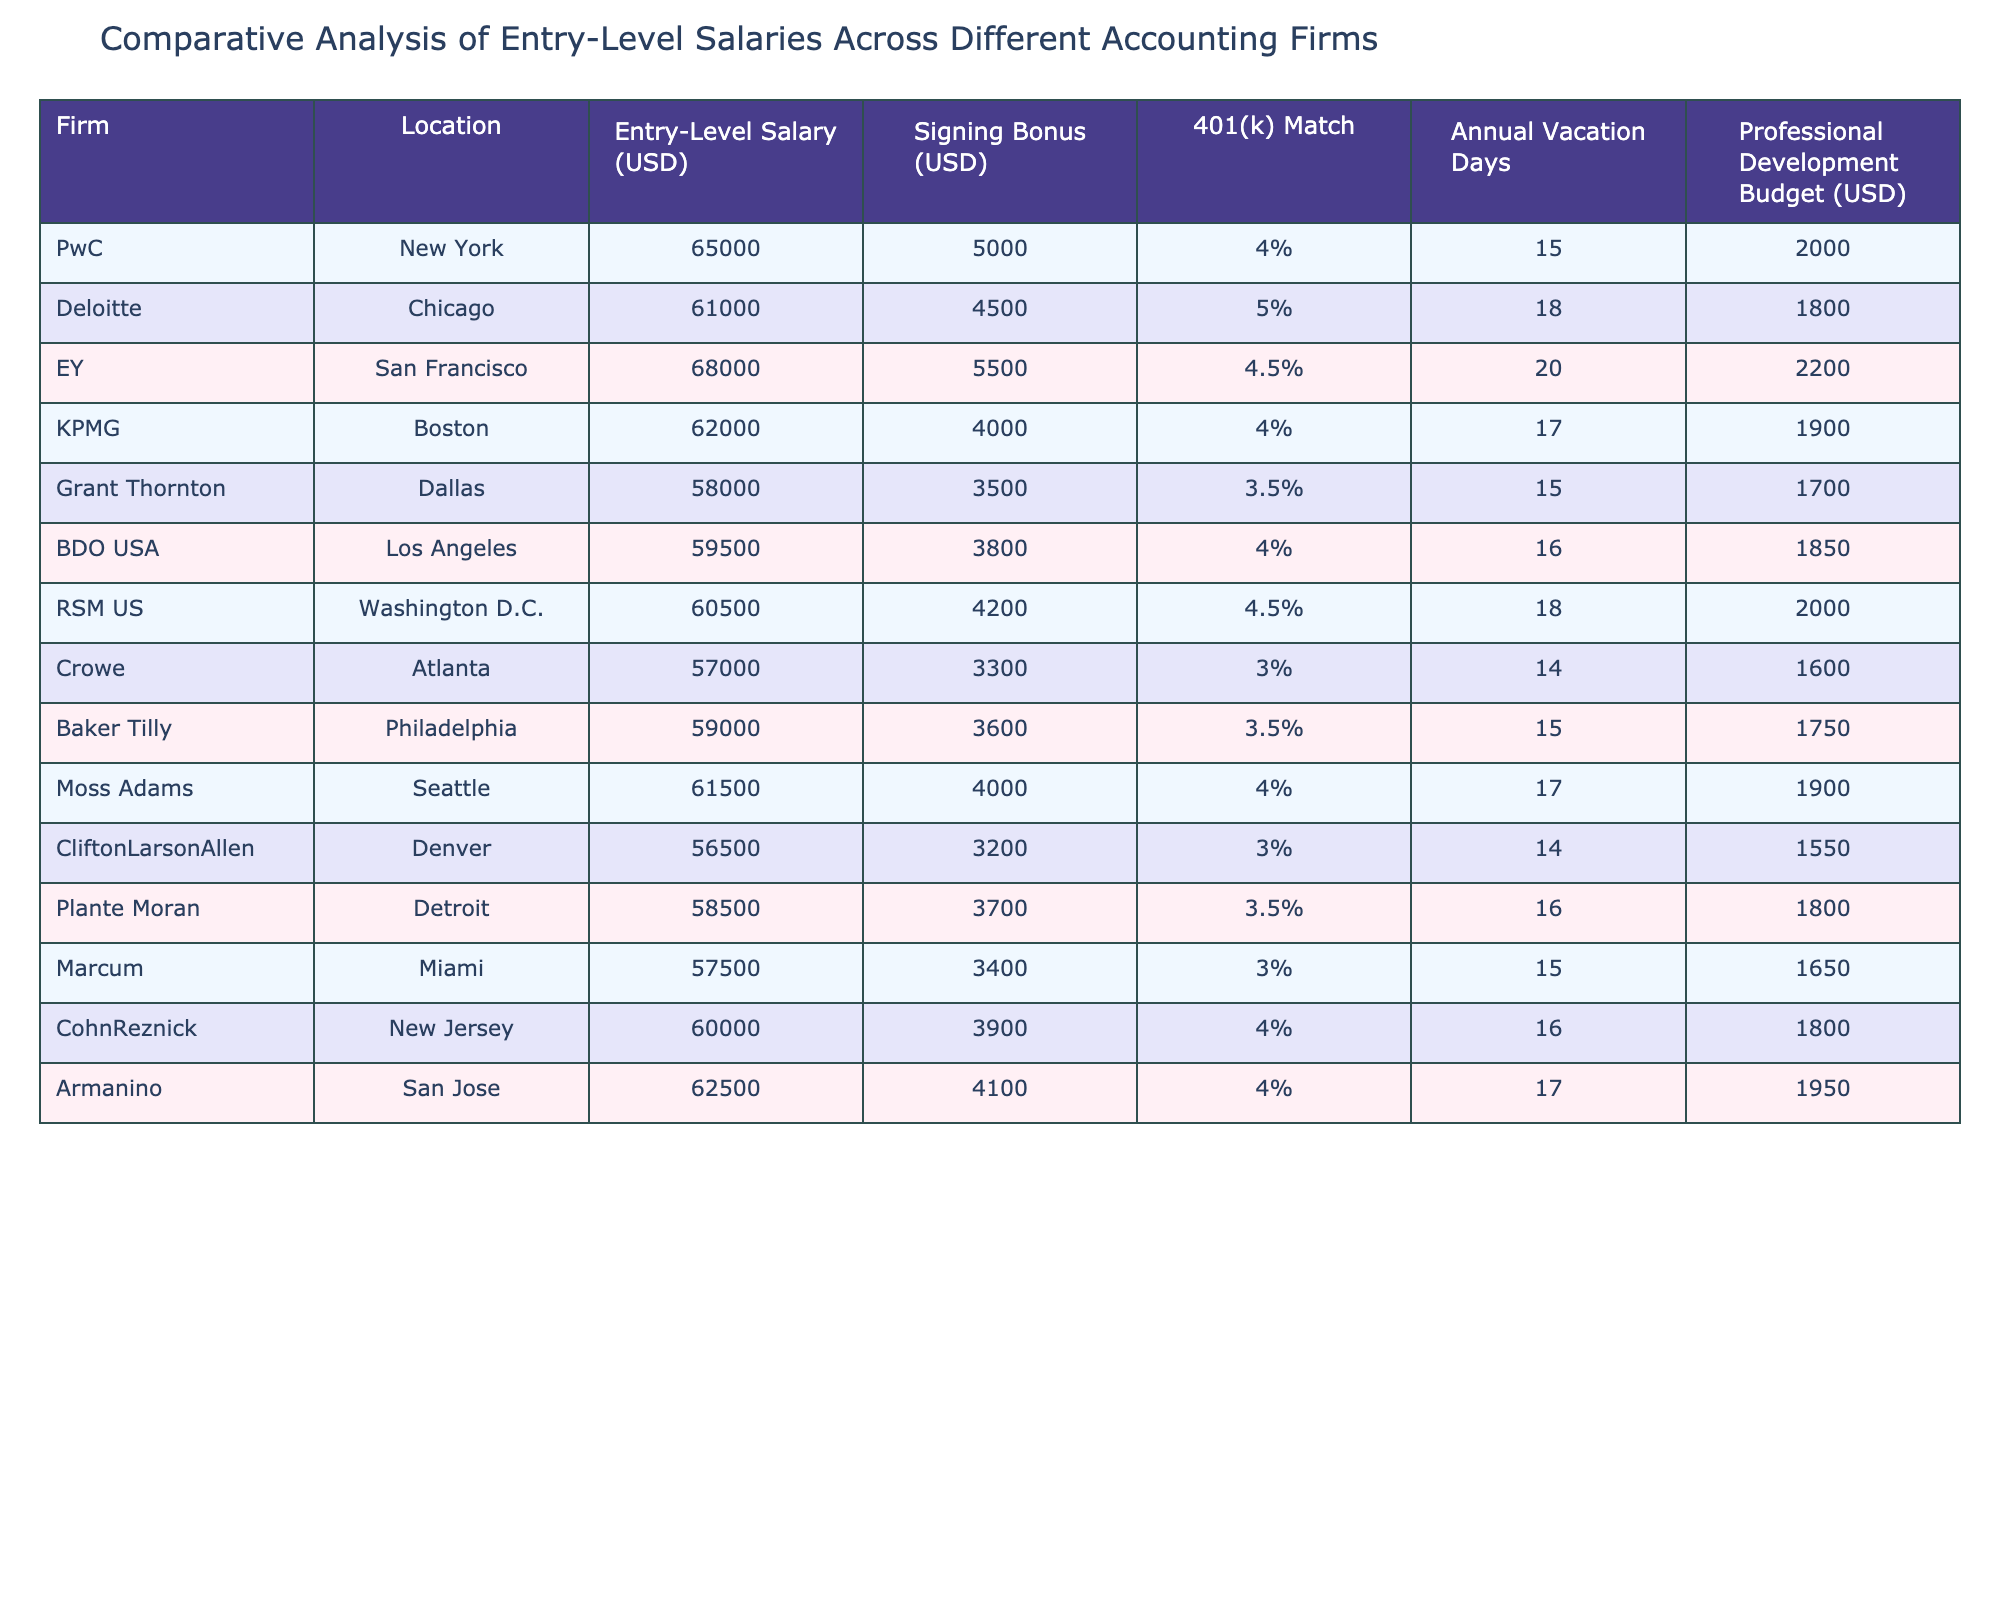What is the highest entry-level salary among the listed firms? By examining the "Entry-Level Salary (USD)" column in the table, the highest salary appears for EY at 68,000.
Answer: 68,000 Which firm offers the highest signing bonus? Looking at the "Signing Bonus (USD)" column, EY has the highest signing bonus at 5,500.
Answer: 5,500 What is the average entry-level salary across all firms? To find the average, sum all the entry-level salaries (65,000 + 61,000 + 68,000 + 62,000 + 58,000 + 59,500 + 60,500 + 57,000 + 59,000 + 61,500 + 56,500 + 58,500 + 57,500 + 60,000 + 62,500) totaling 899,500, then divide by 15 (the number of firms), which equals 59,966.67.
Answer: 59,966.67 Does KPMG offer a better 401(k) match than Grant Thornton? KPMG has a 401(k) match of 4%, while Grant Thornton has a match of 3.5%. Therefore, KPMG does offer a better match compared to Grant Thornton.
Answer: Yes Which city has the highest average entry-level salary among the listed firms? To find the city with the highest average, we can sum the salaries of the firms located in each city and divide by the number of firms. For example, New York (65,000), Chicago (61,000), San Francisco (68,000), and so on. Comparing averages reveals that San Francisco's average salary is the highest at 68,000.
Answer: San Francisco If a candidate received the average signing bonus from the firms, how much would they earn in total? Calculate the average signing bonus by summing (5,000 + 4,500 + 5,500 + 4,000 + 3,500 + 3,800 + 4,200 + 3,300 + 3,600 + 4,000 + 3,200 + 3,700 + 3,400 + 3,900 + 4,100) totaling 60,300 and divide by 15, resulting in an average signing bonus of 4,020. Adding this to the average entry-level salary of 59,966.67 gives a total of 63,986.67.
Answer: 63,986.67 Are there any firms that offer more than 20 vacation days? By checking the "Annual Vacation Days" column, we see that no firms offer more than 20 vacation days; the highest is 20 days from EY.
Answer: No Which firm has the least professional development budget, and what is the amount? Look at the "Professional Development Budget (USD)" column, where CliftonLarsonAllen shows the least budget at 1,550.
Answer: CliftonLarsonAllen, 1,550 What is the total annual vacation days provided by all firms? Add the vacation days from all firms (15 + 18 + 20 + 17 + 15 + 16 + 18 + 14 + 15 + 17 + 14 + 16 + 15 + 16 + 17) totaling 250 annual vacation days across all firms.
Answer: 250 Which firm has an entry-level salary lower than the average salary but offers more vacation days than the average? The average salary is 59,966.67. Firms below this amount are Grant Thornton (58,000), BDO USA (59,500), Crowe (57,000), Baker Tilly (59,000), and Marcum (57,500). Among these, only Deloitte (18 vacation days), KPMG (17), and RSM US (18) have vacation days above 15. Therefore, Deloitte qualifies as it has both an entry-level salary below the average and more vacation days.
Answer: Deloitte 